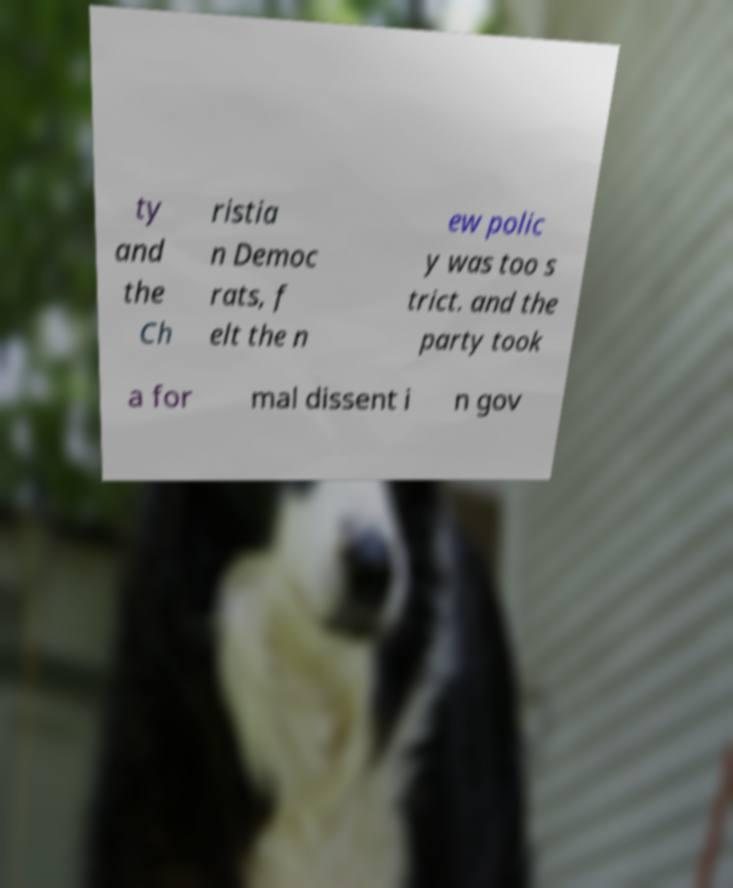Please identify and transcribe the text found in this image. ty and the Ch ristia n Democ rats, f elt the n ew polic y was too s trict. and the party took a for mal dissent i n gov 